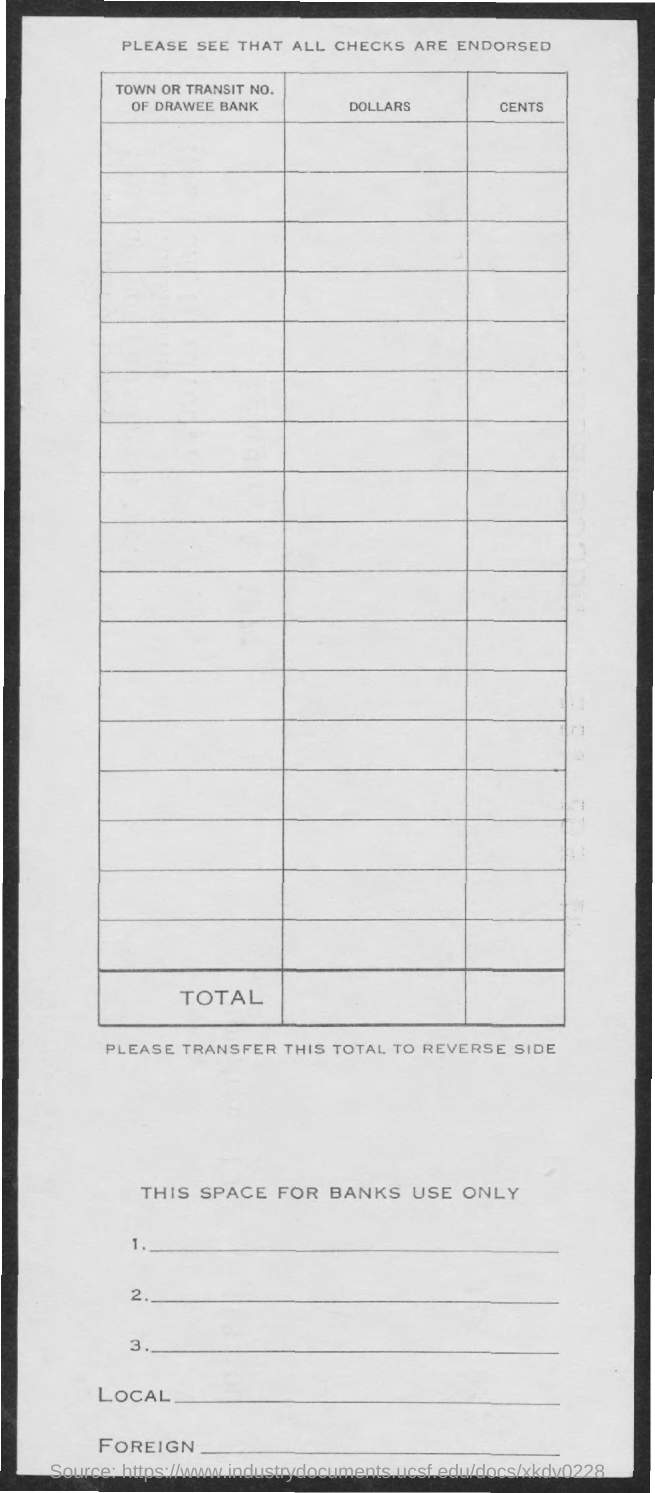What is the title of the second column?
Your answer should be compact. Dollars. What is the title of the third column?
Ensure brevity in your answer.  Cents. 